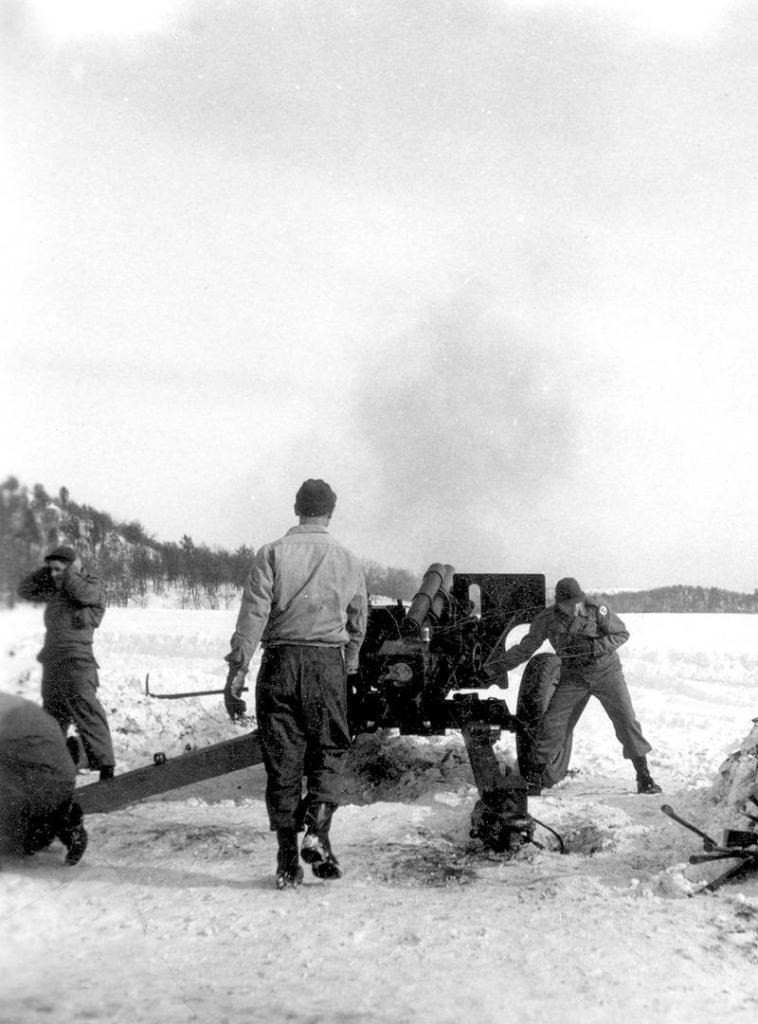Who or what is present in the image? There are people in the image. What are the people doing in the image? The people are standing beside a missile and operating it. What can be seen in the background of the image? There are trees on a mountain in the background of the image. What color is the chalk used by the people in the image? There is no chalk present in the image; the people are operating a missile. How far away is the mountain from the people in the image? The distance between the people and the mountain cannot be determined from the image. 